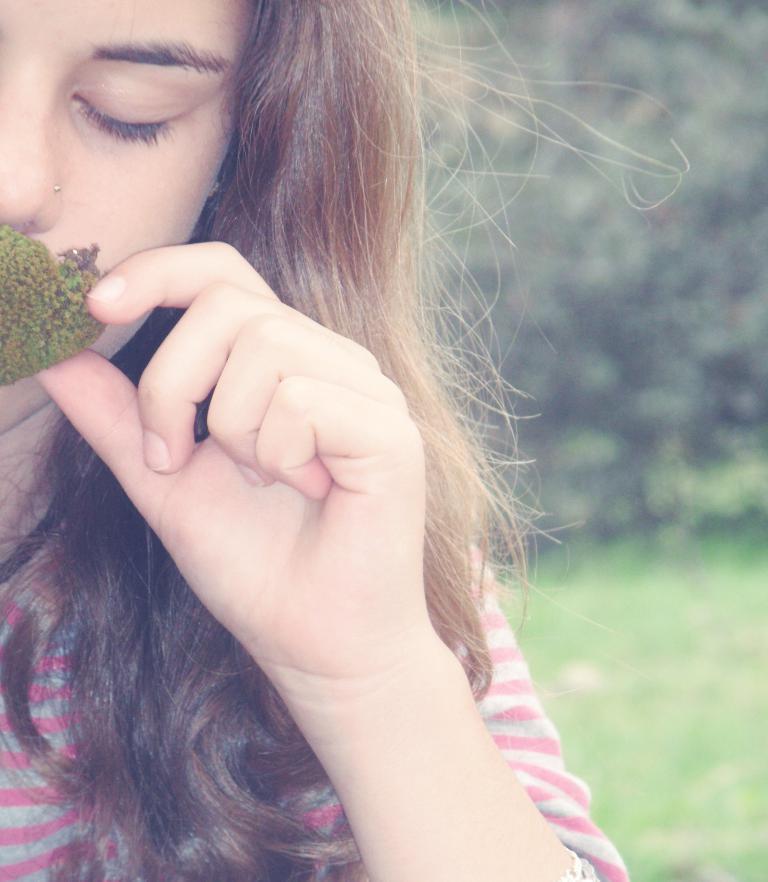Please provide a concise description of this image. This picture shows a woman. She is holding a bud in her hand and we see trees and grass on the ground. 